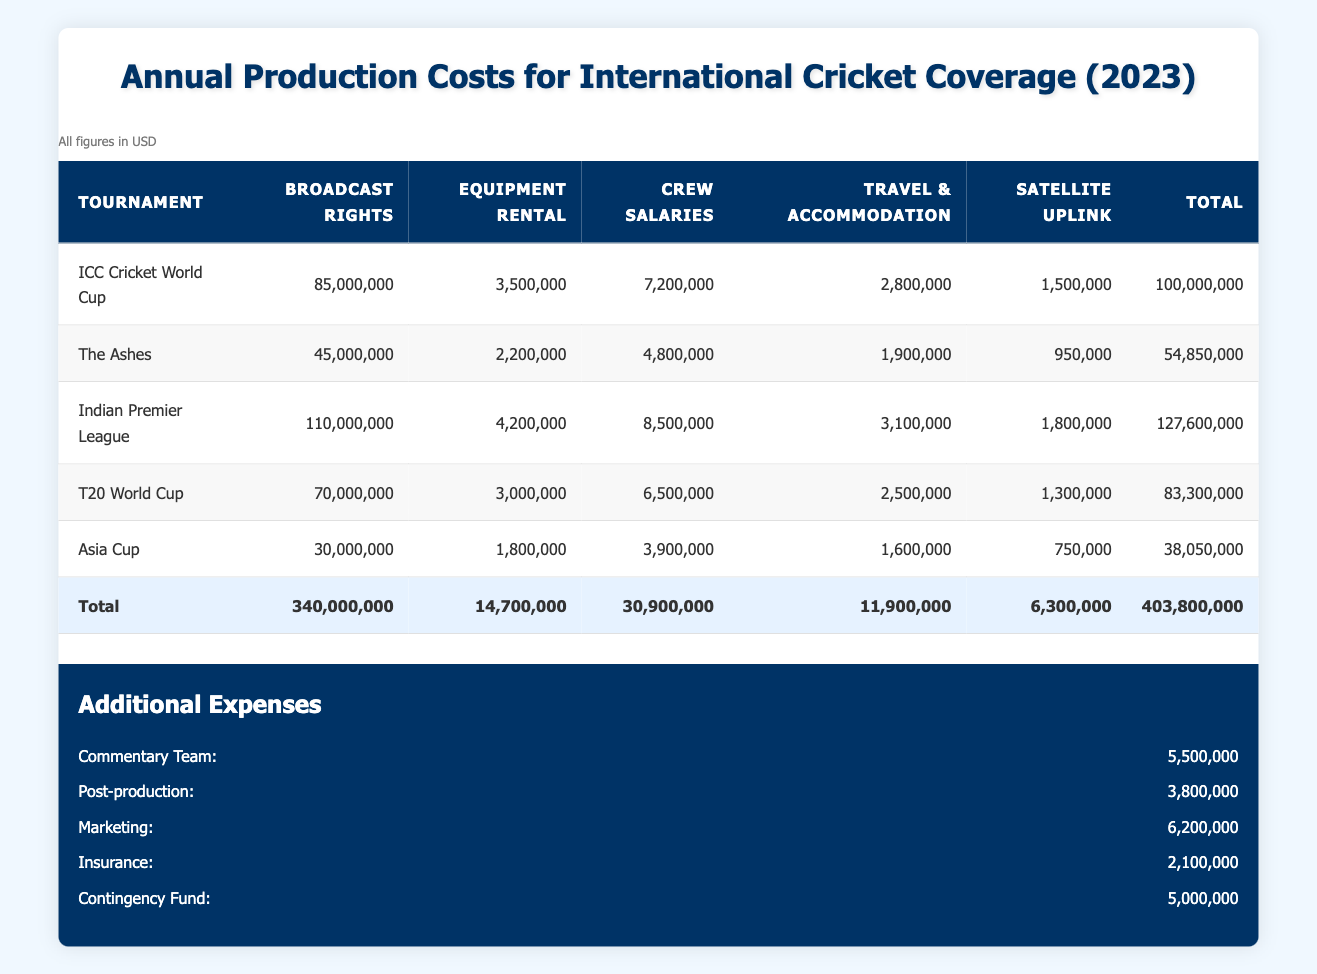What is the total cost for the ICC Cricket World Cup? The total cost for the ICC Cricket World Cup is listed in the table under the "Total" column for that tournament, which is 100,000,000.
Answer: 100,000,000 Which tournament has the highest broadcast rights cost? By comparing the "Broadcast Rights" column across all tournaments, the Indian Premier League has the highest cost at 110,000,000.
Answer: Indian Premier League What is the combined total for broadcast rights across all tournaments? To find this, I add together the broadcast rights for all tournaments: 85,000,000 + 45,000,000 + 110,000,000 + 70,000,000 + 30,000,000 = 340,000,000.
Answer: 340,000,000 Is the total cost for The Ashes greater than the total cost for the Asia Cup? The total cost for The Ashes is 54,850,000, and for the Asia Cup, it is 38,050,000. Since 54,850,000 is greater than 38,050,000, the statement is true.
Answer: Yes What is the average crew salary expenditure across the tournaments listed? The crew salaries for each tournament are 7,200,000, 4,800,000, 8,500,000, 6,500,000, and 3,900,000. To find the average: (7,200,000 + 4,800,000 + 8,500,000 + 6,500,000 + 3,900,000) / 5 = 6,180,000.
Answer: 6,180,000 Which tournament has the lowest travel and accommodation costs? By inspecting the "Travel & Accommodation" column, the Asia Cup has the lowest cost listed at 1,600,000.
Answer: Asia Cup What are the total additional expenses? To find the total additional expenses, I add all the additional costs listed: 5,500,000 + 3,800,000 + 6,200,000 + 2,100,000 + 5,000,000 = 22,600,000.
Answer: 22,600,000 Is the total production cost for the Indian Premier League higher than the total production cost for the ICC Cricket World Cup? The total for the Indian Premier League is 127,600,000, while for the ICC Cricket World Cup it is 100,000,000. Since 127,600,000 is indeed greater than 100,000,000, the answer is yes.
Answer: Yes What percentage of the total production costs do the additional expenses represent? The total production costs are 403,800,000. The additional expenses total 22,600,000. The percentage is calculated as (22,600,000 / 403,800,000) * 100, which gives approximately 5.59%.
Answer: Approximately 5.59% 